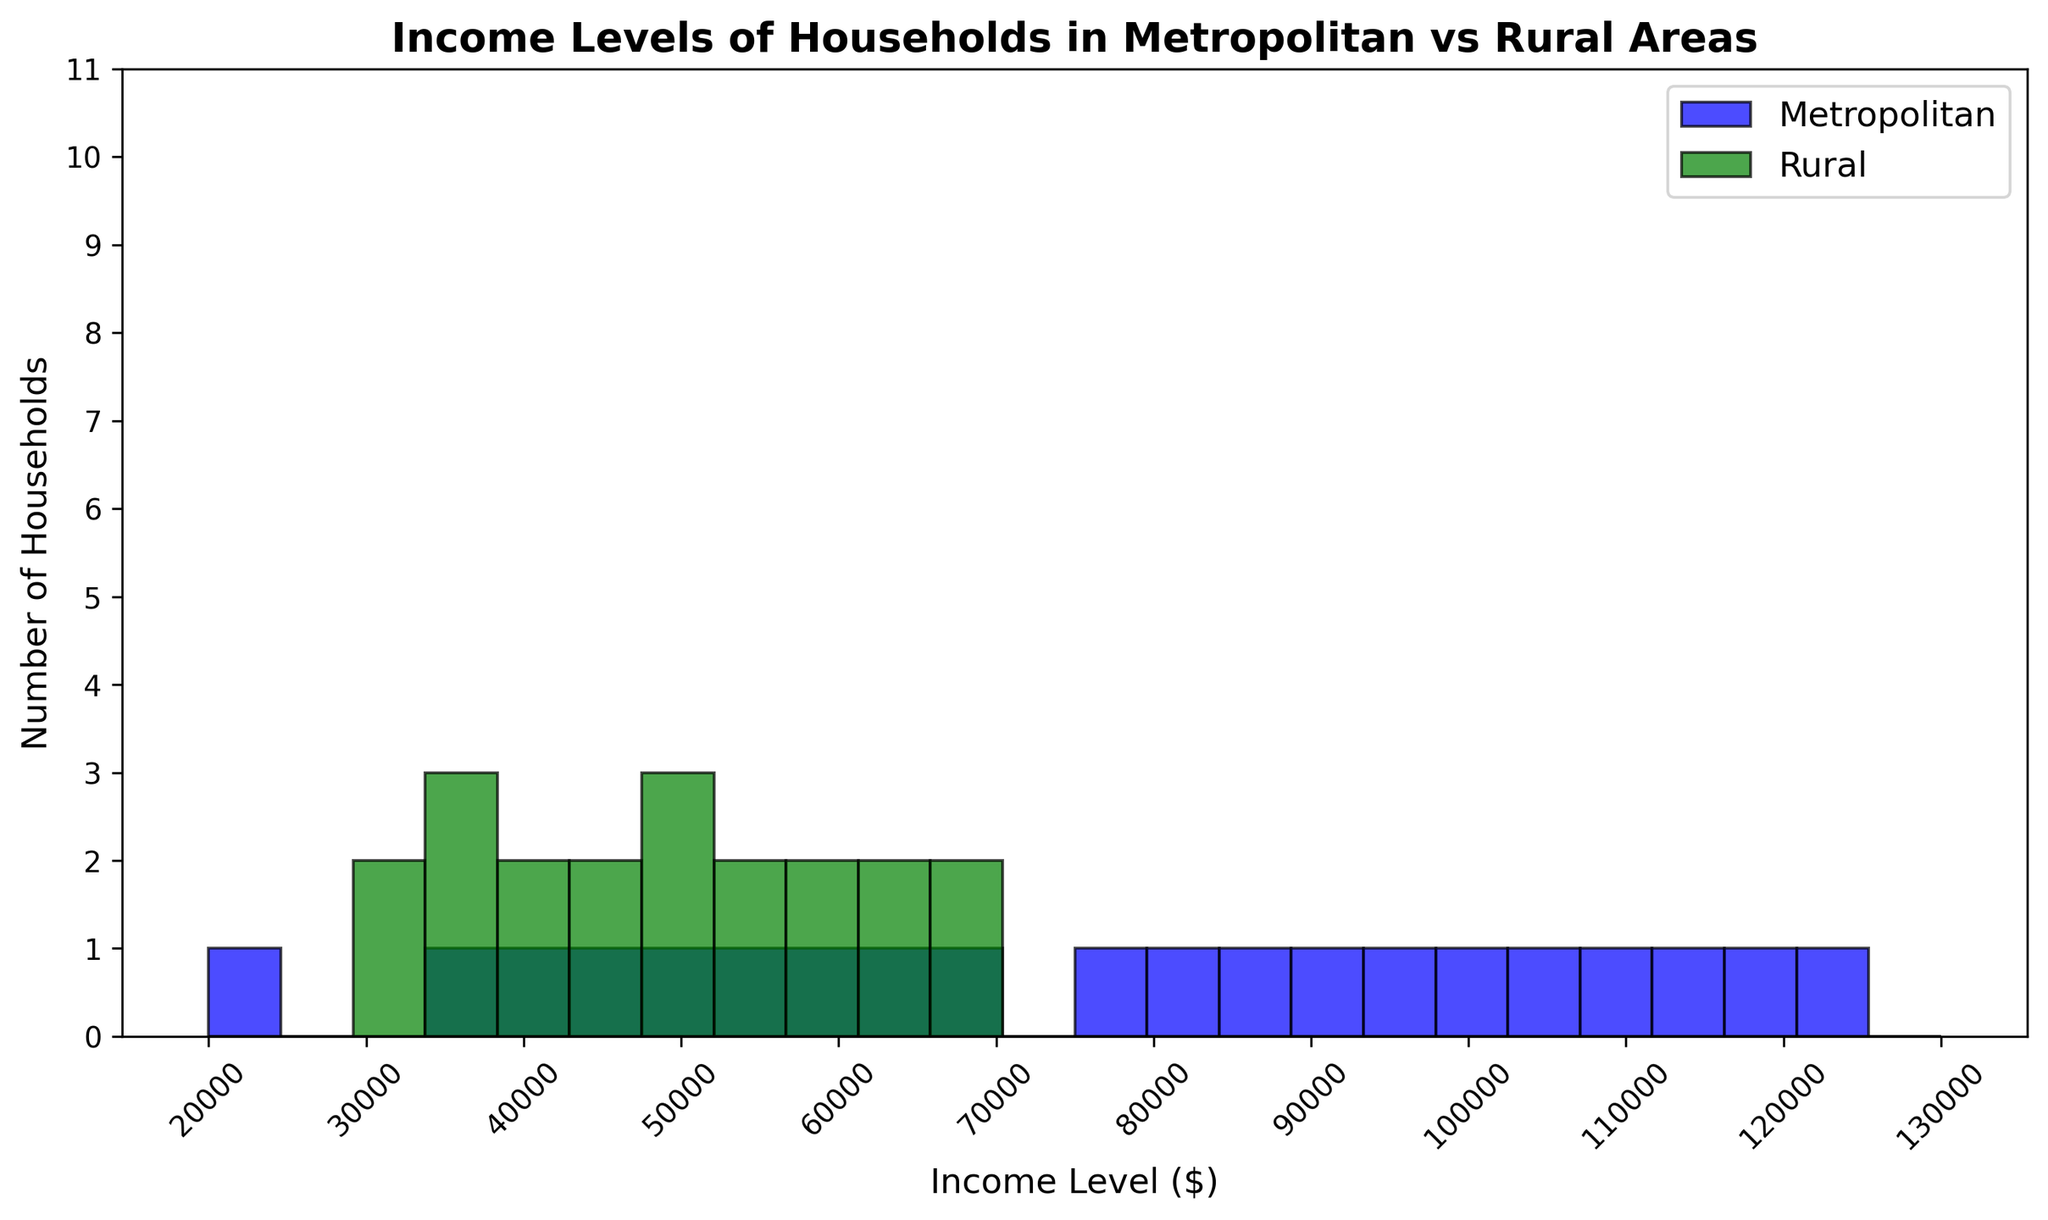How does the highest income level in metropolitan areas compare to the highest income level in rural areas? The histogram shows the maximum income level for metropolitan households at $125,000, while the maximum for rural households is $68,000. Compare these values directly to see how they differ.
Answer: Metropolitan: $125,000; Rural: $68,000 Which area has a wider range of income levels? The range of income levels is determined by the difference between the highest and lowest values. For metropolitan areas, the range is $125,000 - $20,000 = $105,000. For rural areas, the range is $68,000 - $30,000 = $38,000. Metropolitan areas have a wider range.
Answer: Metropolitan In which income bracket ($20,000 to $70,000) do metropolitan households dominate over rural households? Look for income brackets within $20,000 to $70,000 where the number of metropolitan households exceeds the number of rural households based on histogram heights. Metropolitan areas have more households in all income brackets within this range.
Answer: All brackets within $20,000 to $70,000 What is the approximate number of rural households in the $50,000 - $60,000 income bracket? Identify the height of the histogram bar corresponding to the $50,000 - $60,000 income bracket for rural households. It appears to be about 2.
Answer: 2 households Is there an income bracket where rural households are more than metropolitan households? Check the histogram bars across all income brackets to see if any rural bar height exceeds the corresponding metropolitan bar height. In this figure, no such bracket shows rural households outnumbering metropolitan households.
Answer: No How do the income distributions of metropolitan and rural households visually differ? Examine the shape and spread of the histogram bars for both areas. Metropolitan income distribution is wider and skews higher with more high-income households, while rural income levels are more concentrated in the lower brackets.
Answer: Metropolitan: wider & higher skew; Rural: more concentrated lower What's the most common income level for metropolitan households? Identify the tallest bar in the histogram for metropolitan areas, which indicates the most frequent income level. The tallest bar is around the $50,000 - $60,000 range.
Answer: $50,000 - $60,000 range How many income brackets are there where the number of metropolitan households is at least twice the number of rural households? Compare the heights of the bars in each income bracket and count how many times the metropolitan bar is at least twice as tall as the rural bar. This occurs in most of the brackets from $40,000 to $100,000.
Answer: Approximately 6-8 brackets By visual inspection, what can you infer about the economic disparity between metropolitan and rural households? Assess the overall spread and height of the bars. Metropolitan households are spread across a wider range of income levels and generally appear to have higher incomes than rural households, indicating greater economic disparity.
Answer: Metropolitan incomes are generally higher and more varied 